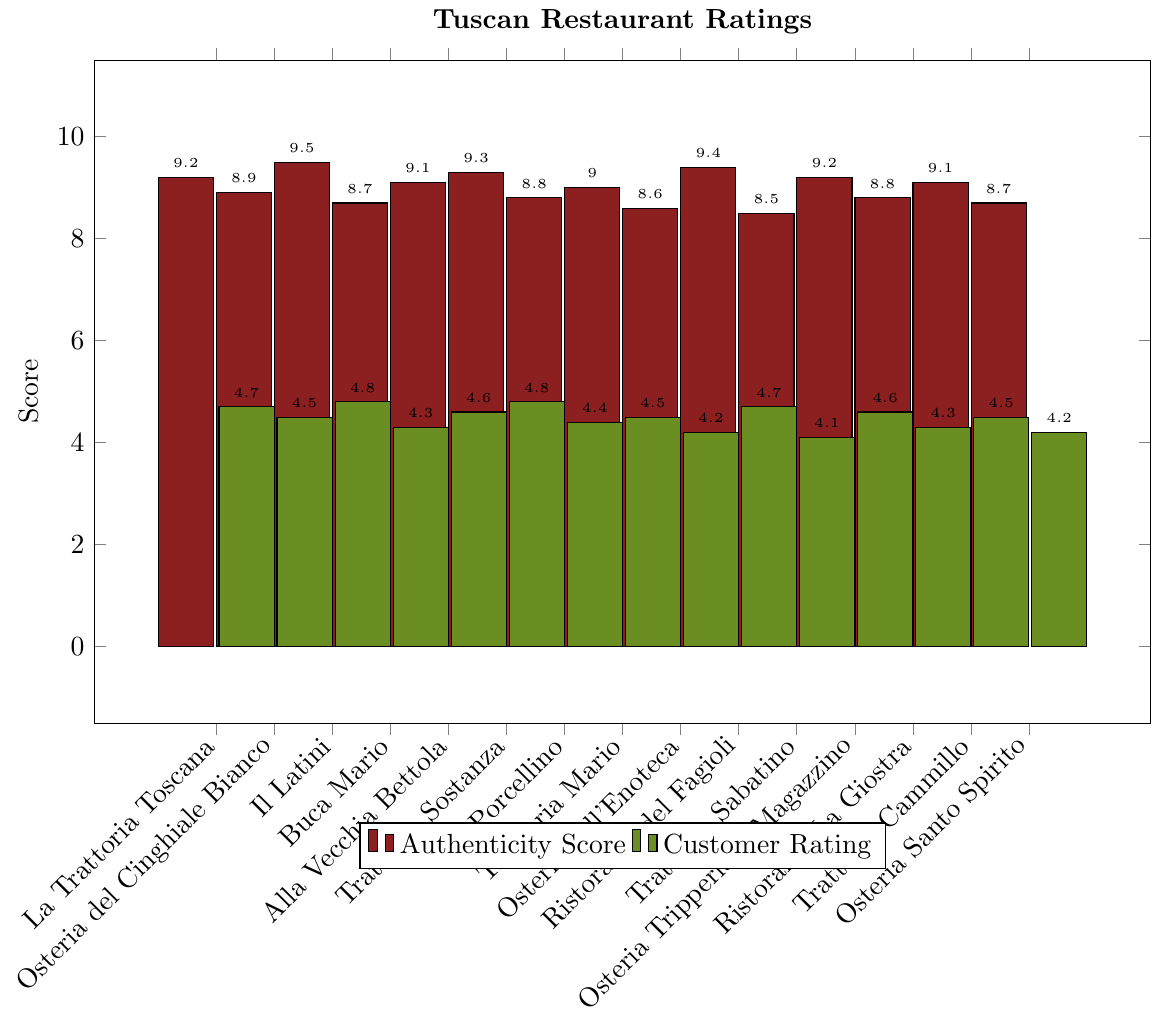What's the authenticity score of the highest-rated restaurant in customer ratings? The highest customer rating in the figure is 4.8, applying to 'Il Latini' and 'Trattoria Sostanza', both with authenticity scores of 9.5 and 9.3, respectively.
Answer: 9.5 and 9.3 Which restaurant has the lowest customer rating? By observing the plot, 'Trattoria Sabatino' has the lowest customer rating with a score of 4.1.
Answer: Trattoria Sabatino What is the difference in customer ratings between 'Osteria dell'Enoteca' and 'Osteria Santo Spirito'? Identify the customer ratings for both restaurants: 4.2 for 'Osteria dell'Enoteca' and 4.2 for 'Osteria Santo Spirito'. Calculate the difference: 4.2 - 4.2 = 0.
Answer: 0 How many restaurants have an authenticity score of 9.0 or higher? Count the bars that have an authenticity score of 9.0 or higher: 'La Trattoria Toscana', 'Il Latini', 'Alla Vecchia Bettola', 'Trattoria Sostanza', 'Trattoria Mario', 'Ristorante del Fagioli', 'Osteria Tripperia Il Magazzino', and 'Trattoria Cammillo'. That makes 8.
Answer: 8 Which restaurant shows the smallest difference between authenticity score and customer rating? Calculate the differences between authenticity score and customer rating for each restaurant and find the smallest: 
1. 'La Trattoria Toscana' → 9.2 - 4.7 = 4.5
2. 'Osteria del Cinghiale Bianco' → 8.9 - 4.5 = 4.4
3. 'Il Latini' → 9.5 - 4.8 = 4.7
4. 'Buca Mario' → 8.7 - 4.3 = 4.4
5. 'Alla Vecchia Bettola' → 9.1 - 4.6 = 4.5
6. 'Trattoria Sostanza' → 9.3 - 4.8 = 4.5
7. 'Il Porcellino' → 8.8 - 4.4 = 4.4
...
The smallest difference is 4.1-4.1 found with 'Ristorante La Giostra'.
Answer: Ristorante La Giostra Identify the restaurant with the highest customer rating, but an authenticity score below 9.0. Check the customer ratings and authenticity scores and select those with an authenticity score below 9.0. 'Osteria del Cinghiale Bianco', 'Buca Mario', 'Il Porcellino', 'Osteria dell'Enoteca', 'Trattoria Sabatino', 'Ristorante La Giostra', 'Osteria Santo Spirito'. Among these 'Osteria del Cinghiale Bianco' has the highest customer rating with 4.5.
Answer: Osteria del Cinghiale Bianco What is the total sum of the authenticity scores of all restaurants? Sum the authenticity scores for all the restaurants listed: 9.2 + 8.9 + 9.5 + 8.7 + 9.1 + 9.3 + 8.8 + 9.0 + 8.6 + 9.4 + 8.5 + 9.2 + 8.8 + 9.1 + 8.7 = 133.8.
Answer: 133.8 